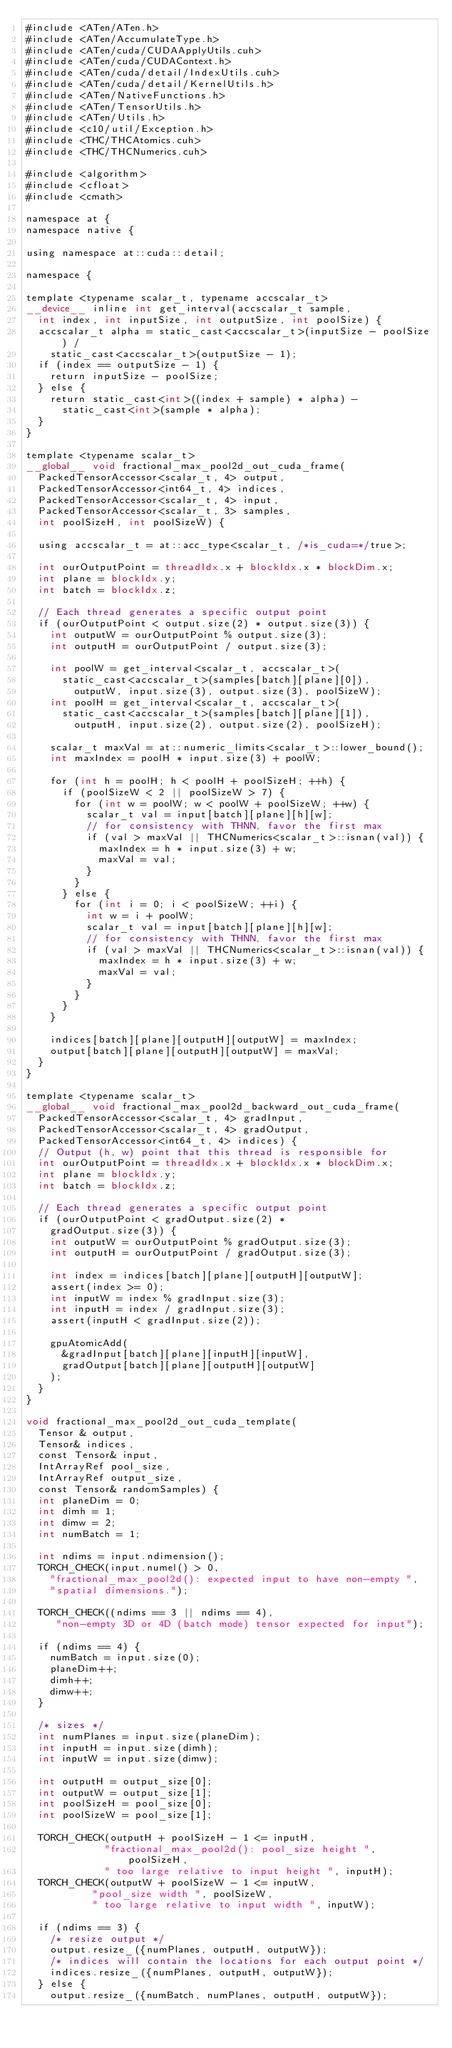Convert code to text. <code><loc_0><loc_0><loc_500><loc_500><_Cuda_>#include <ATen/ATen.h>
#include <ATen/AccumulateType.h>
#include <ATen/cuda/CUDAApplyUtils.cuh>
#include <ATen/cuda/CUDAContext.h>
#include <ATen/cuda/detail/IndexUtils.cuh>
#include <ATen/cuda/detail/KernelUtils.h>
#include <ATen/NativeFunctions.h>
#include <ATen/TensorUtils.h>
#include <ATen/Utils.h>
#include <c10/util/Exception.h>
#include <THC/THCAtomics.cuh>
#include <THC/THCNumerics.cuh>

#include <algorithm>
#include <cfloat>
#include <cmath>

namespace at {
namespace native {

using namespace at::cuda::detail;

namespace {

template <typename scalar_t, typename accscalar_t>
__device__ inline int get_interval(accscalar_t sample,
  int index, int inputSize, int outputSize, int poolSize) {
  accscalar_t alpha = static_cast<accscalar_t>(inputSize - poolSize) /
    static_cast<accscalar_t>(outputSize - 1);
  if (index == outputSize - 1) {
    return inputSize - poolSize;
  } else {
    return static_cast<int>((index + sample) * alpha) -
      static_cast<int>(sample * alpha);
  }
}

template <typename scalar_t>
__global__ void fractional_max_pool2d_out_cuda_frame(
  PackedTensorAccessor<scalar_t, 4> output,
  PackedTensorAccessor<int64_t, 4> indices,
  PackedTensorAccessor<scalar_t, 4> input,
  PackedTensorAccessor<scalar_t, 3> samples,
  int poolSizeH, int poolSizeW) {

  using accscalar_t = at::acc_type<scalar_t, /*is_cuda=*/true>;

  int ourOutputPoint = threadIdx.x + blockIdx.x * blockDim.x;
  int plane = blockIdx.y;
  int batch = blockIdx.z;

  // Each thread generates a specific output point
  if (ourOutputPoint < output.size(2) * output.size(3)) {
    int outputW = ourOutputPoint % output.size(3);
    int outputH = ourOutputPoint / output.size(3);

    int poolW = get_interval<scalar_t, accscalar_t>(
      static_cast<accscalar_t>(samples[batch][plane][0]),
        outputW, input.size(3), output.size(3), poolSizeW);
    int poolH = get_interval<scalar_t, accscalar_t>(
      static_cast<accscalar_t>(samples[batch][plane][1]),
        outputH, input.size(2), output.size(2), poolSizeH);

    scalar_t maxVal = at::numeric_limits<scalar_t>::lower_bound();
    int maxIndex = poolH * input.size(3) + poolW;

    for (int h = poolH; h < poolH + poolSizeH; ++h) {
      if (poolSizeW < 2 || poolSizeW > 7) {
        for (int w = poolW; w < poolW + poolSizeW; ++w) {
          scalar_t val = input[batch][plane][h][w];
          // for consistency with THNN, favor the first max
          if (val > maxVal || THCNumerics<scalar_t>::isnan(val)) {
            maxIndex = h * input.size(3) + w;
            maxVal = val;
          }
        }
      } else {
        for (int i = 0; i < poolSizeW; ++i) {
          int w = i + poolW;
          scalar_t val = input[batch][plane][h][w];
          // for consistency with THNN, favor the first max
          if (val > maxVal || THCNumerics<scalar_t>::isnan(val)) {
            maxIndex = h * input.size(3) + w;
            maxVal = val;
          }
        }
      }
    }

    indices[batch][plane][outputH][outputW] = maxIndex;
    output[batch][plane][outputH][outputW] = maxVal;
  }
}

template <typename scalar_t>
__global__ void fractional_max_pool2d_backward_out_cuda_frame(
  PackedTensorAccessor<scalar_t, 4> gradInput,
  PackedTensorAccessor<scalar_t, 4> gradOutput,
  PackedTensorAccessor<int64_t, 4> indices) {
  // Output (h, w) point that this thread is responsible for
  int ourOutputPoint = threadIdx.x + blockIdx.x * blockDim.x;
  int plane = blockIdx.y;
  int batch = blockIdx.z;

  // Each thread generates a specific output point
  if (ourOutputPoint < gradOutput.size(2) *
    gradOutput.size(3)) {
    int outputW = ourOutputPoint % gradOutput.size(3);
    int outputH = ourOutputPoint / gradOutput.size(3);

    int index = indices[batch][plane][outputH][outputW];
    assert(index >= 0);
    int inputW = index % gradInput.size(3);
    int inputH = index / gradInput.size(3);
    assert(inputH < gradInput.size(2));

    gpuAtomicAdd(
      &gradInput[batch][plane][inputH][inputW],
      gradOutput[batch][plane][outputH][outputW]
    );
  }
}

void fractional_max_pool2d_out_cuda_template(
  Tensor & output,
  Tensor& indices,
  const Tensor& input,
  IntArrayRef pool_size,
  IntArrayRef output_size,
  const Tensor& randomSamples) {
  int planeDim = 0;
  int dimh = 1;
  int dimw = 2;
  int numBatch = 1;

  int ndims = input.ndimension();
  TORCH_CHECK(input.numel() > 0,
    "fractional_max_pool2d(): expected input to have non-empty ",
    "spatial dimensions.");

  TORCH_CHECK((ndims == 3 || ndims == 4),
     "non-empty 3D or 4D (batch mode) tensor expected for input");

  if (ndims == 4) {
    numBatch = input.size(0);
    planeDim++;
    dimh++;
    dimw++;
  }

  /* sizes */
  int numPlanes = input.size(planeDim);
  int inputH = input.size(dimh);
  int inputW = input.size(dimw);

  int outputH = output_size[0];
  int outputW = output_size[1];
  int poolSizeH = pool_size[0];
  int poolSizeW = pool_size[1];

  TORCH_CHECK(outputH + poolSizeH - 1 <= inputH,
             "fractional_max_pool2d(): pool_size height ", poolSizeH,
             " too large relative to input height ", inputH);
  TORCH_CHECK(outputW + poolSizeW - 1 <= inputW,
           "pool_size width ", poolSizeW,
           " too large relative to input width ", inputW);

  if (ndims == 3) {
    /* resize output */
    output.resize_({numPlanes, outputH, outputW});
    /* indices will contain the locations for each output point */
    indices.resize_({numPlanes, outputH, outputW});
  } else {
    output.resize_({numBatch, numPlanes, outputH, outputW});</code> 